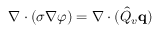Convert formula to latex. <formula><loc_0><loc_0><loc_500><loc_500>\nabla \cdot ( \sigma \nabla \varphi ) = \nabla \cdot ( \hat { Q } _ { v } q )</formula> 